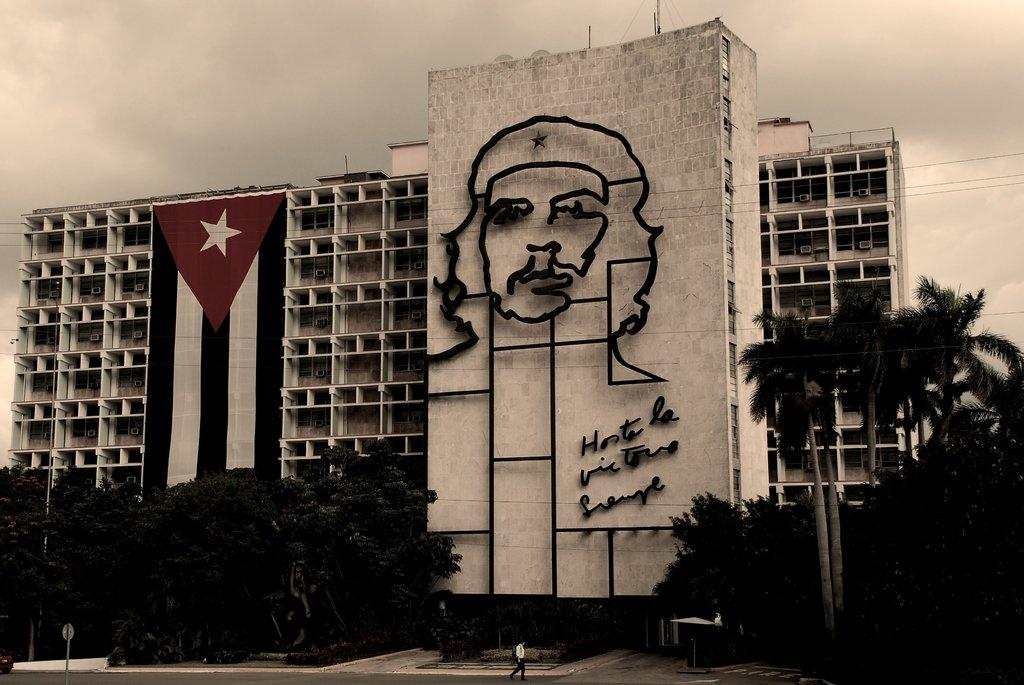What type of structure is visible in the image? There is a building with windows in the image. What natural elements can be seen in the image? There are trees in the image. What is the person in the image doing? There is a person walking on the road in the image. What can be seen in the background of the image? The sky with clouds is visible in the background of the image. Where is the faucet located in the image? There is no faucet present in the image. What type of support is the person using to walk in the image? The person is walking on the road without any visible support. 